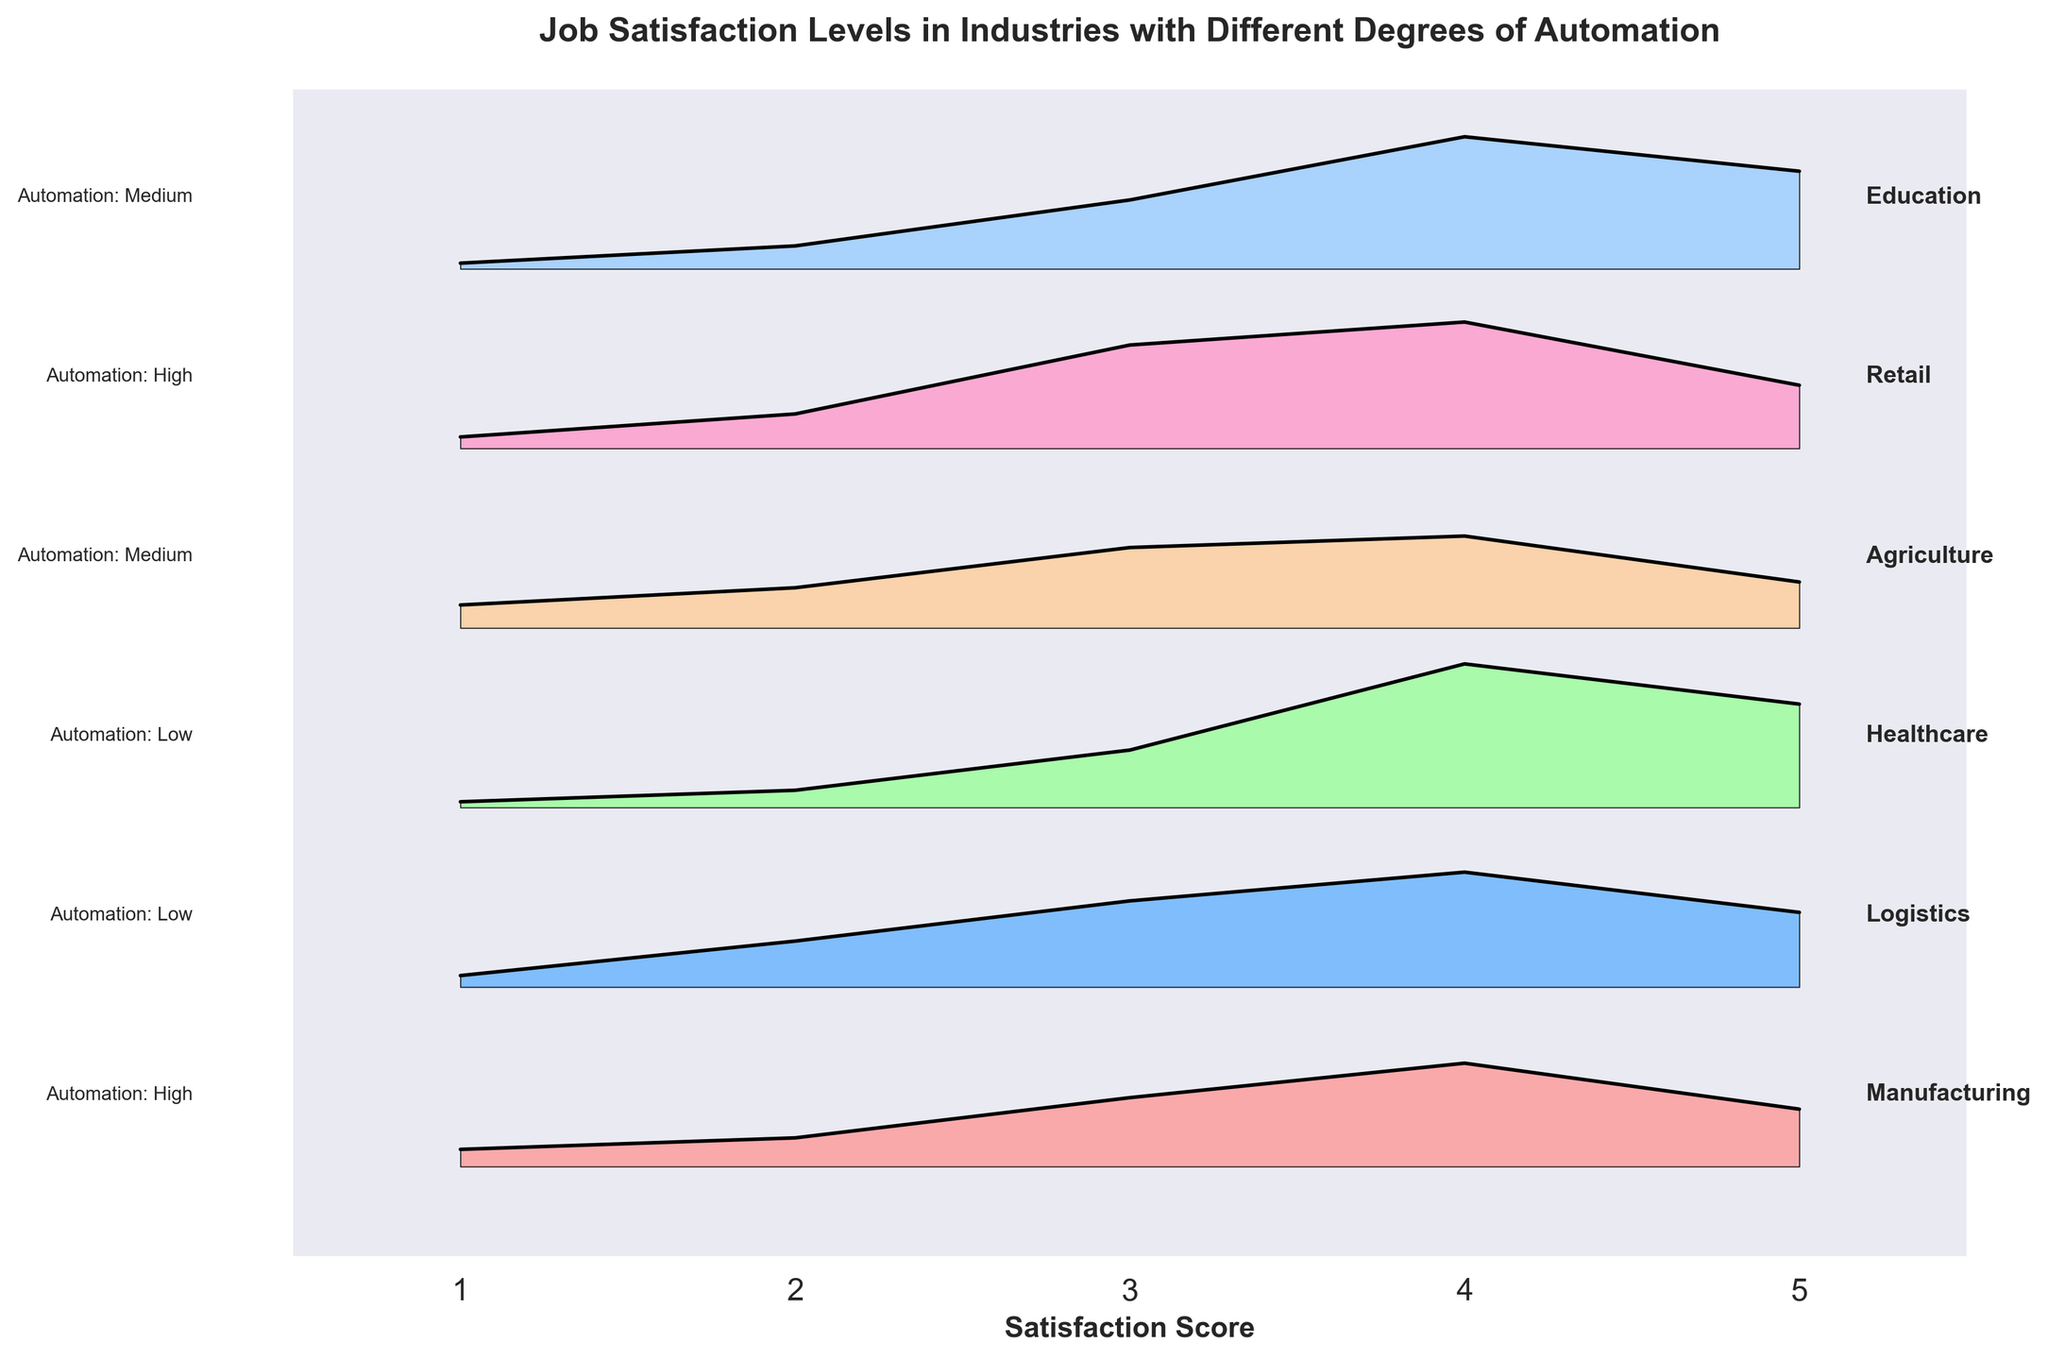what is the title of the plot? The title is usually placed at the top center of the plot. It helps to describe what the plot is about. In this case, the title reads: 'Job Satisfaction Levels in Industries with Different Degrees of Automation'.
Answer: Job Satisfaction Levels in Industries with Different Degrees of Automation Which industry has the highest satisfaction score most frequently? From the plot, we can see the distribution of satisfaction scores by industry. The industry with the highest peak at the satisfaction score of 5 represents the most frequent high satisfaction score.
Answer: Healthcare What is the automation level of the Healthcare industry? The automation level is typically mentioned alongside the industry names. In this plot, it states that Healthcare has a 'Low' automation level.
Answer: Low Which two industries have high automation levels? By looking at each industry label along with its associated automation level, we can identify 'Manufacturing' and 'Agriculture' as the industries with high automation levels.
Answer: Manufacturing, Agriculture Among industries with medium automation, which has a higher frequency at satisfaction score 3: Logistics or Retail? By comparing the frequencies at satisfaction score 3 for Logistics and Retail, we see that Retail has a higher peak compared to Logistics.
Answer: Retail What are the satisfaction scores shown on the x-axis? The x-axis displays the range of satisfaction scores evaluated in the plot. These scores typically range from 1 to 5.
Answer: 1, 2, 3, 4, 5 How does the satisfaction score distribution for Education compare to Retail? Education has a lower frequency at satisfaction score 3 compared to Retail but a relatively higher frequency at scores 4 and 5. Retail peaks significantly at satisfaction score 4.
Answer: Education has lower at 3, higher at 4 and 5 Which industry shows a notable peak at satisfaction score 4? By observing the plot, we can identify that several industries show notable peaks at satisfaction score 4, but Healthcare and Education have the most prominent peaks at score 4.
Answer: Healthcare, Education Is there any industry with all satisfaction scores having a frequency greater than 5? To answer this, we scan each industry segment to ensure no segment has a frequency below 5 across all satisfaction scores. There is no industry that fulfills this condition as some entries have frequencies like 1 or 2.
Answer: No 